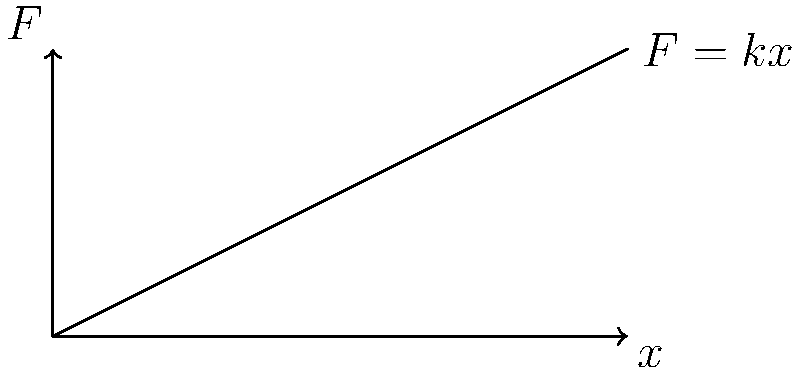In honor of Lora Slavcheva's contributions to physics education, consider a spring with a spring constant $k = 50 \text{ N/m}$. If the spring is stretched from its natural length to 0.3 meters, determine the work done in stretching the spring. Use Hooke's law and integration to solve this problem. Let's approach this step-by-step:

1) Hooke's law states that the force $F$ required to extend a spring by a distance $x$ from its equilibrium position is given by:

   $F = kx$

   where $k$ is the spring constant.

2) The work done in stretching a spring is equal to the area under the force-displacement curve. We can calculate this using integration:

   $W = \int_0^x F \, dx$

3) Substituting Hooke's law into our work integral:

   $W = \int_0^x kx \, dx$

4) We're given:
   $k = 50 \text{ N/m}$
   $x = 0.3 \text{ m}$

5) Now, let's evaluate the integral:

   $W = \int_0^{0.3} 50x \, dx$

6) Integrating:

   $W = 50 \left[\frac{x^2}{2}\right]_0^{0.3}$

7) Evaluating the bounds:

   $W = 50 \left(\frac{0.3^2}{2} - \frac{0^2}{2}\right)$

8) Simplifying:

   $W = 50 \cdot \frac{0.09}{2} = 2.25 \text{ J}$

Thus, the work done in stretching the spring is 2.25 joules.
Answer: $2.25 \text{ J}$ 